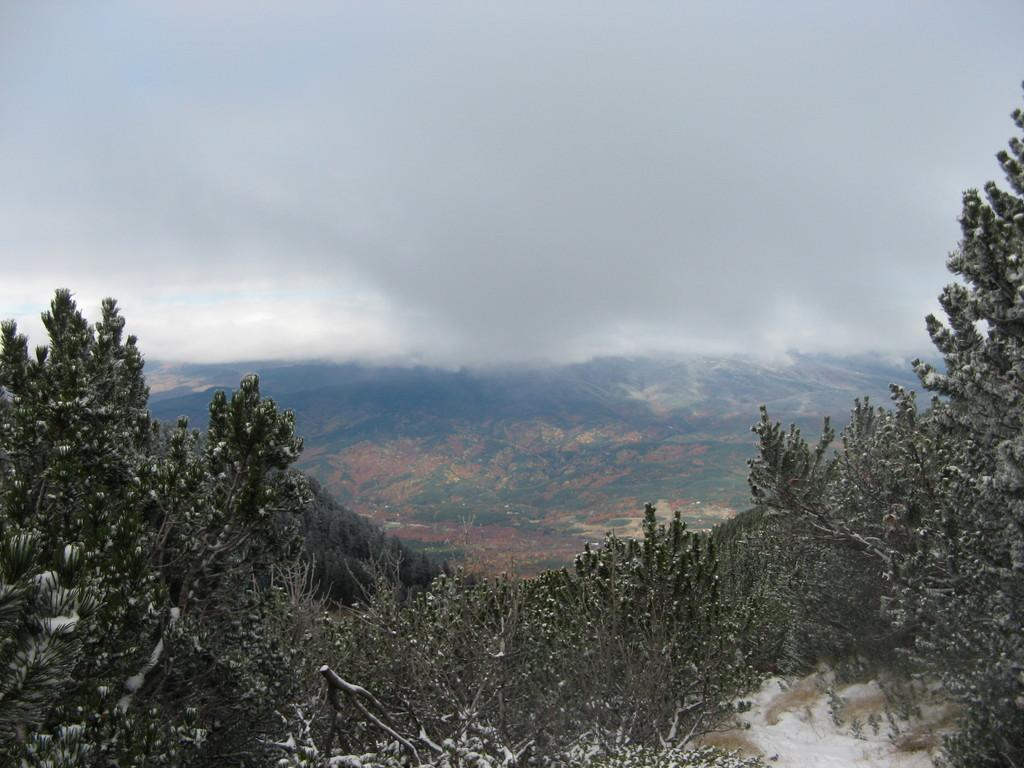What type of vegetation is at the bottom of the picture? There are trees at the bottom of the picture. What type of landscape feature can be seen in the background of the picture? There are hills in the background of the picture. What part of the natural environment is visible at the top of the picture? The sky is visible at the top of the picture. Where was the image taken? The image was taken in the outskirts. What color is the daughter's door in the image? There is no daughter or door present in the image. How many wings can be seen on the trees in the image? There are no wings visible in the image; only trees are present. 